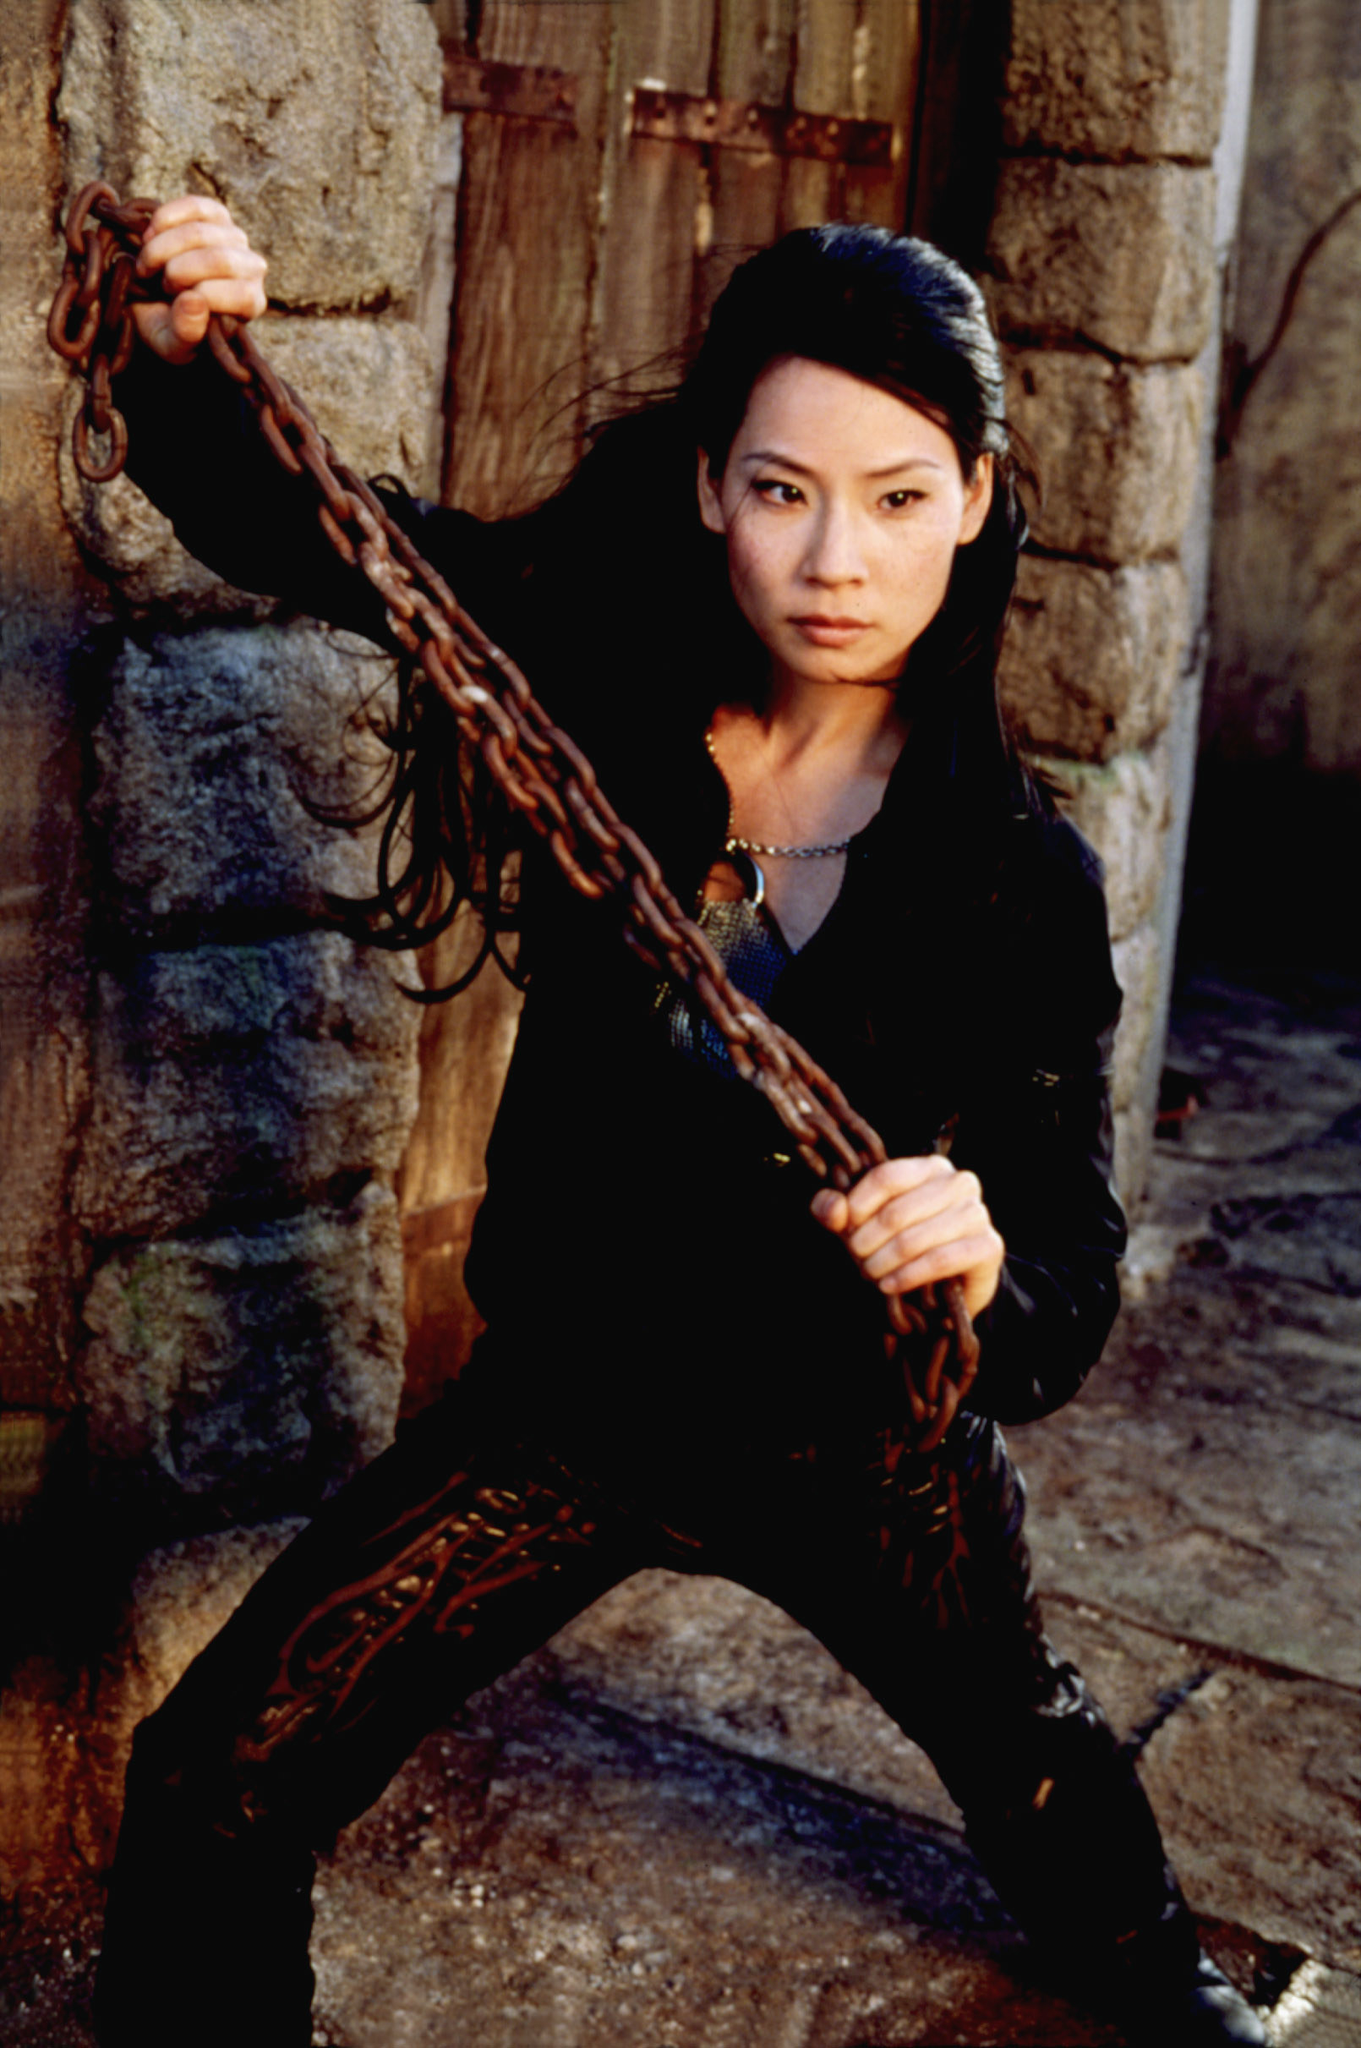Imagine a surreal scenario involving this character. In a surreal twist, the character is suddenly transported into an ethereal forest where the chains in her hands transform into glowing vines. These vines pulse with a vibrant light of multiple colors, reflecting her emotions and thoughts. The rugged stone walls morph into towering, luminous trees, and the wooden door becomes a gateway to a parallel universe. The character now embodies a guardian of this mystical realm, her necklace radiating energy as it connects her to the heart of the forest. This new-found power allows her to communicate with the ethereal beings residing in the forest and protect the mystical balance of this enchanting world. How does she use her new powers in this mystical realm? Embracing her role as the guardian of the forest, she uses her glowing vines to heal the wounded plants and creatures that inhabit this mystical realm. Her necklace acts as a conduit, allowing her to tap into ancient knowledge and wield elemental powers. She can summon rain to nurture the flora, command the wind to clear paths, and create barriers of light to protect against any dark forces. The character moves gracefully through the forest, each step rejuvenating the land. Her presence brings a sense of calm and balance, ensuring that the mystical realm thrives under her watchful eye. What’s a day in the life like for this character in the surreal forest? A day in the life of this character in the surreal forest is filled with harmonious tasks. She wakes up at dawn, the first light of day gently easing her from slumber. Her morning begins with a ritual walk through the forest, during which she communicates with the spirits of the trees and animals, ensuring all is well. She then spends her day nurturing the ecosystem, using her glowing vines to heal and enhance the vitality of the landscape. She holds counsel with the ethereal beings, discussing any issues that need addressing. In the evenings, she guards the mystical gateways, ensuring no dark forces penetrate her tranquil realm. Her night ends with a serene meditation by a luminescent waterfall, recharging her energies for the next day. 